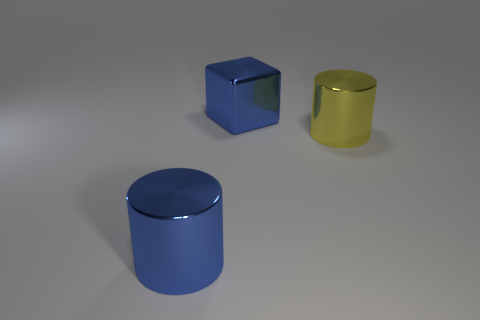Add 3 blocks. How many objects exist? 6 Subtract all cubes. How many objects are left? 2 Add 1 blue shiny cylinders. How many blue shiny cylinders are left? 2 Add 2 yellow cylinders. How many yellow cylinders exist? 3 Subtract 0 yellow cubes. How many objects are left? 3 Subtract all big yellow metal cylinders. Subtract all big blue blocks. How many objects are left? 1 